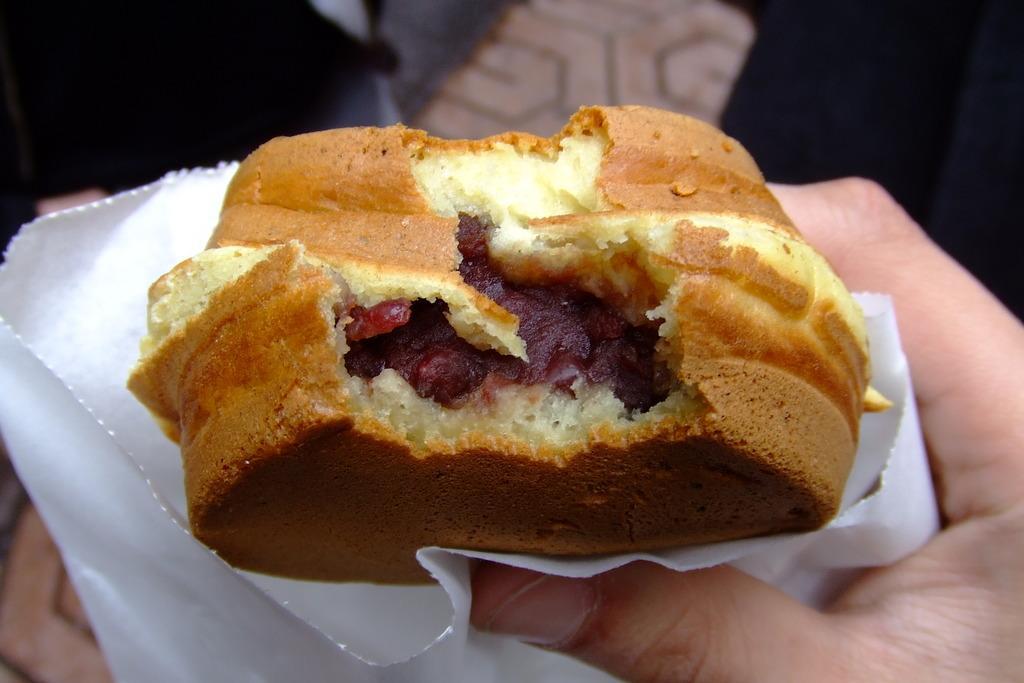In one or two sentences, can you explain what this image depicts? In this image we can see a person's hand holding a burger and there is a napkin. 